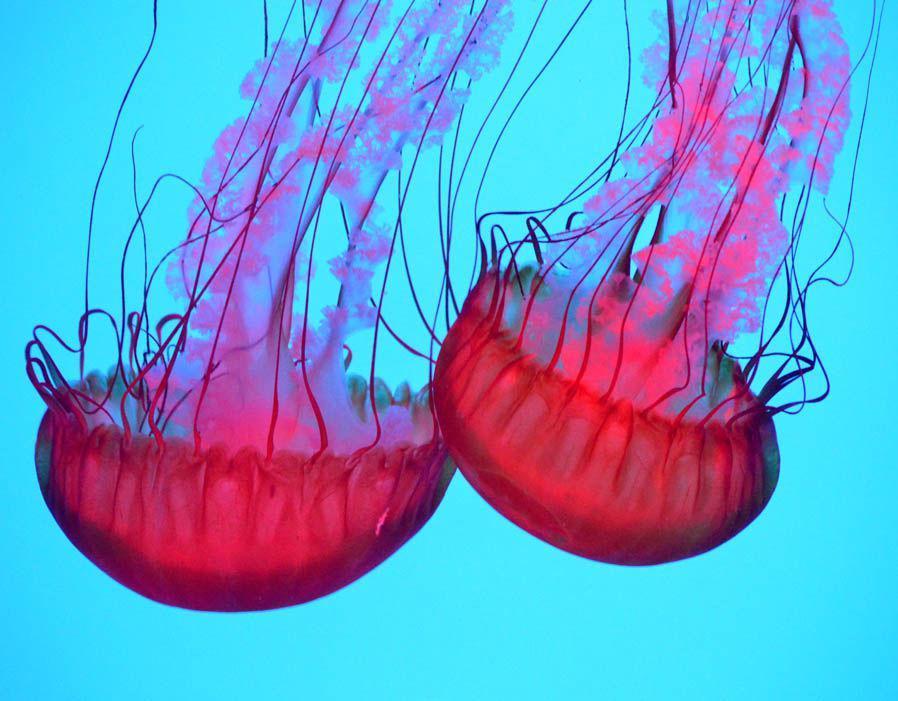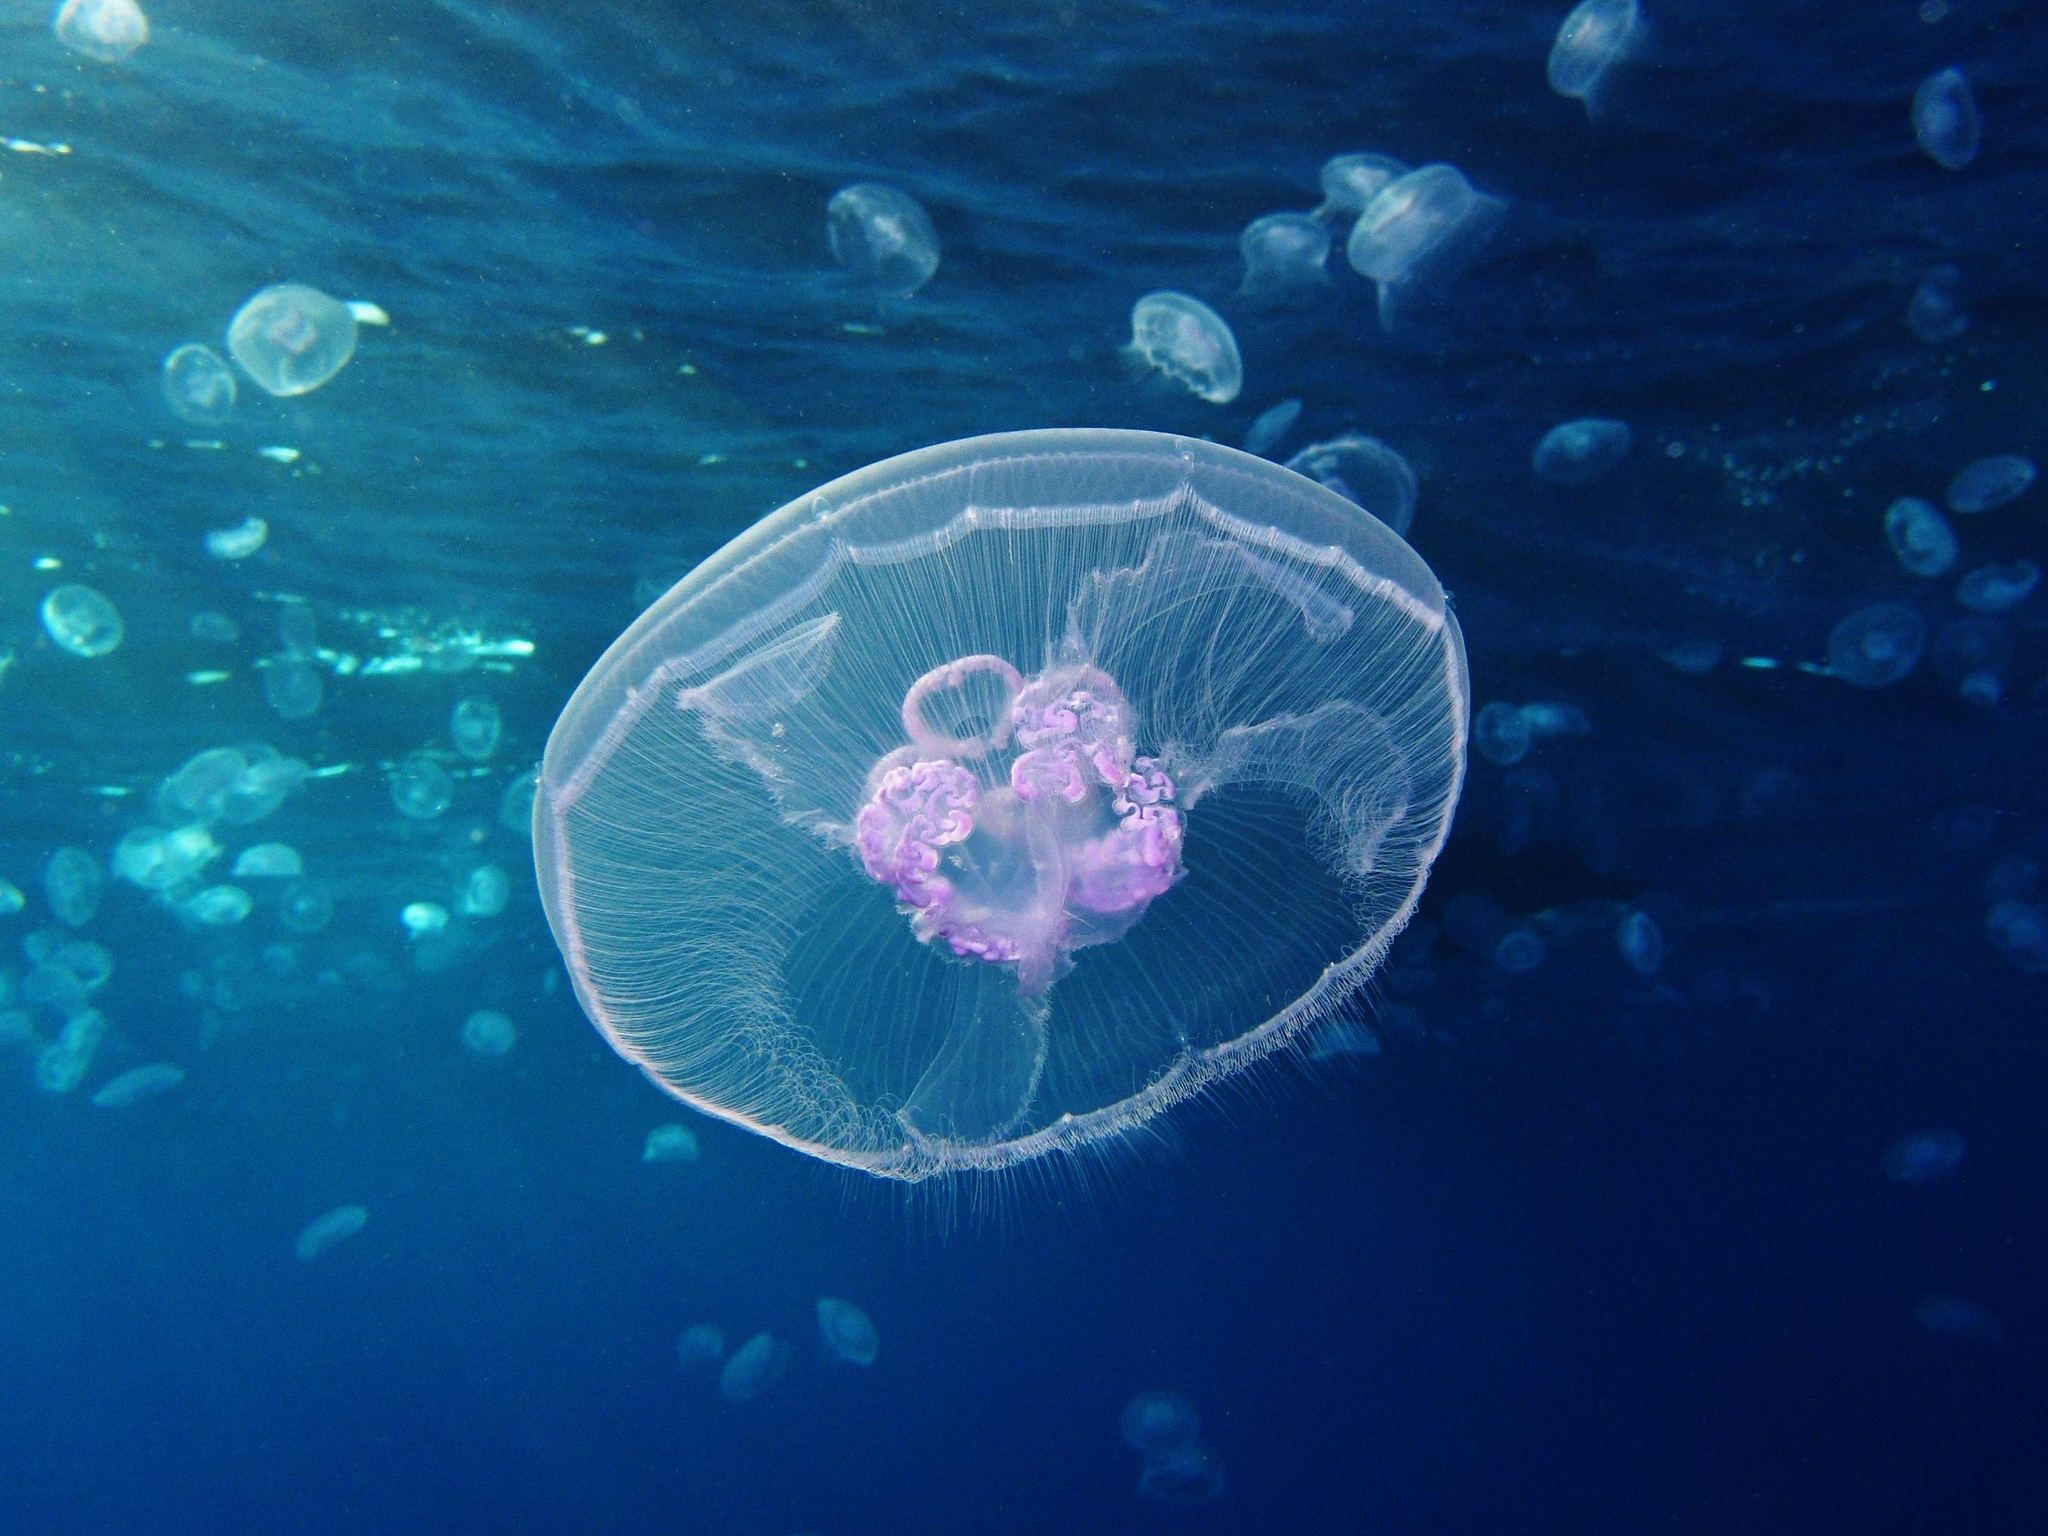The first image is the image on the left, the second image is the image on the right. Examine the images to the left and right. Is the description "The right image contains exactly one pink jellyfish." accurate? Answer yes or no. Yes. The first image is the image on the left, the second image is the image on the right. For the images shown, is this caption "There is a red jellyfish on one of the iamges." true? Answer yes or no. Yes. The first image is the image on the left, the second image is the image on the right. For the images displayed, is the sentence "There are 3 jellyfish." factually correct? Answer yes or no. No. 